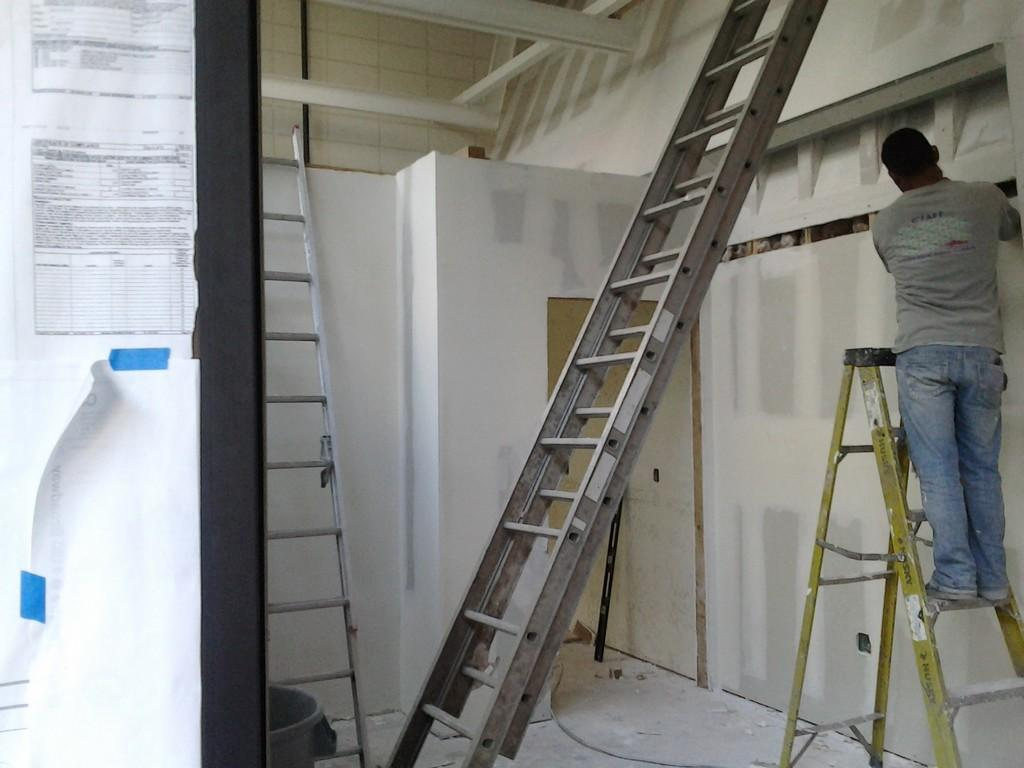What is the person in the image doing? The person is standing on a ladder. How many ladders are visible in the image? There are three ladders visible in the image, with the person standing on one and two additional ladders beside them. What type of gate can be seen in the image? There is no gate present in the image; it only features a person standing on a ladder and two additional ladders beside them. 